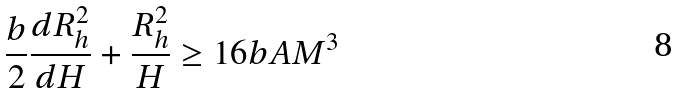Convert formula to latex. <formula><loc_0><loc_0><loc_500><loc_500>\frac { b } { 2 } \frac { d R _ { h } ^ { 2 } } { d H } + \frac { R _ { h } ^ { 2 } } { H } \geq 1 6 b A M ^ { 3 }</formula> 